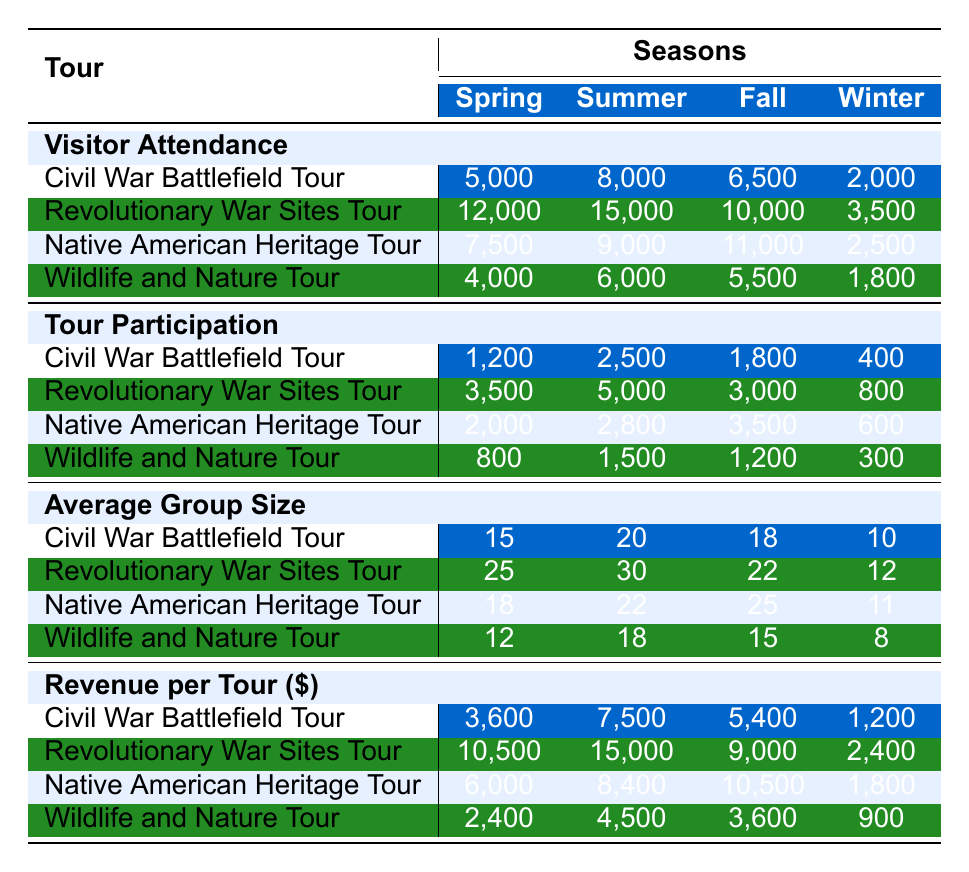What season had the highest visitor attendance for the Revolutionary War Sites Tour? Looking at the visitor attendance for the Revolutionary War Sites Tour across the seasons, the numbers are 12,000 in Spring, 15,000 in Summer, 10,000 in Fall, and 3,500 in Winter. Summer has the highest attendance at 15,000.
Answer: Summer What is the total tour participation for the Wildlife and Nature Tour across all seasons? The tour participation numbers for the Wildlife and Nature Tour are 800 in Spring, 1,500 in Summer, 1,200 in Fall, and 300 in Winter. Adding them up gives 800 + 1500 + 1200 + 300 = 2800.
Answer: 2800 Which tour had the lowest average group size in Winter? The average group sizes in Winter for the tours are 10 for the Civil War Battlefield Tour, 12 for the Revolutionary War Sites Tour, 11 for the Native American Heritage Tour, and 8 for the Wildlife and Nature Tour. The Wildlife and Nature Tour had the lowest average group size of 8.
Answer: Wildlife and Nature Tour How much revenue did the Native American Heritage Tour generate in the Summer? The revenue per tour for the Native American Heritage Tour in Summer is listed as 8,400. This is the amount generated during that season.
Answer: 8400 What is the difference in visitor attendance between Spring and Fall for the Civil War Battlefield Tour? The visitor attendance for the Civil War Battlefield Tour in Spring is 5,000 and in Fall is 6,500. The difference is 6,500 - 5,000 = 1,500.
Answer: 1500 Which season had the highest average group size across all tours? To find the highest average group size, we look at the averages: Spring (15, 25, 18, 12), Summer (20, 30, 22, 18), Fall (18, 22, 25, 15), and Winter (10, 12, 11, 8). Calculating the averages gives Winter an average of 10.5, Spring 17.5, Summer 22.5, and Fall 20. The highest is Summer with 22.5.
Answer: Summer Did the participation in the Civil War Battlefield Tour exceed 2,000 in any season? The participation numbers for the Civil War Battlefield Tour are 1,200 in Spring, 2,500 in Summer, 1,800 in Fall, and 400 in Winter. It exceeded 2,000 in Summer (2,500).
Answer: Yes What is the total revenue generated by the Revolutionary War Sites Tour across all seasons? The revenues for the Revolutionary War Sites Tour are 10,500 in Spring, 15,000 in Summer, 9,000 in Fall, and 2,400 in Winter. Adding these gives 10,500 + 15,000 + 9,000 + 2,400 = 36,900.
Answer: 36900 Which tour had the highest attendance in Winter? In Winter, the visitor attendance numbers for the tours are 2,000 for the Civil War Battlefield Tour, 3,500 for the Revolutionary War Sites Tour, 2,500 for the Native American Heritage Tour, and 1,800 for the Wildlife and Nature Tour. Therefore, the Revolutionary War Sites Tour had the highest attendance in Winter at 3,500.
Answer: Revolutionary War Sites Tour What is the average revenue per tour for the Wildlife and Nature Tour overall? Summing the revenues for the Wildlife and Nature Tour gives 2,400 in Spring, 4,500 in Summer, 3,600 in Fall, and 900 in Winter. This totals 2,400 + 4,500 + 3,600 + 900 = 11,400. The average based on 4 seasons is 11,400 / 4 = 2,850.
Answer: 2850 